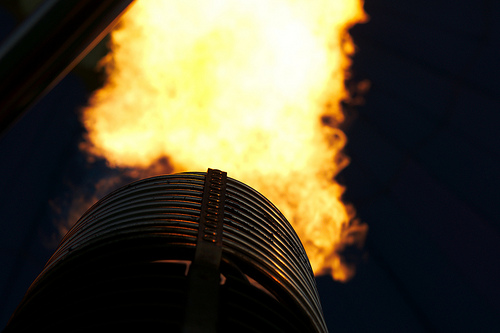<image>
Can you confirm if the fire is in front of the dark? Yes. The fire is positioned in front of the dark, appearing closer to the camera viewpoint. 